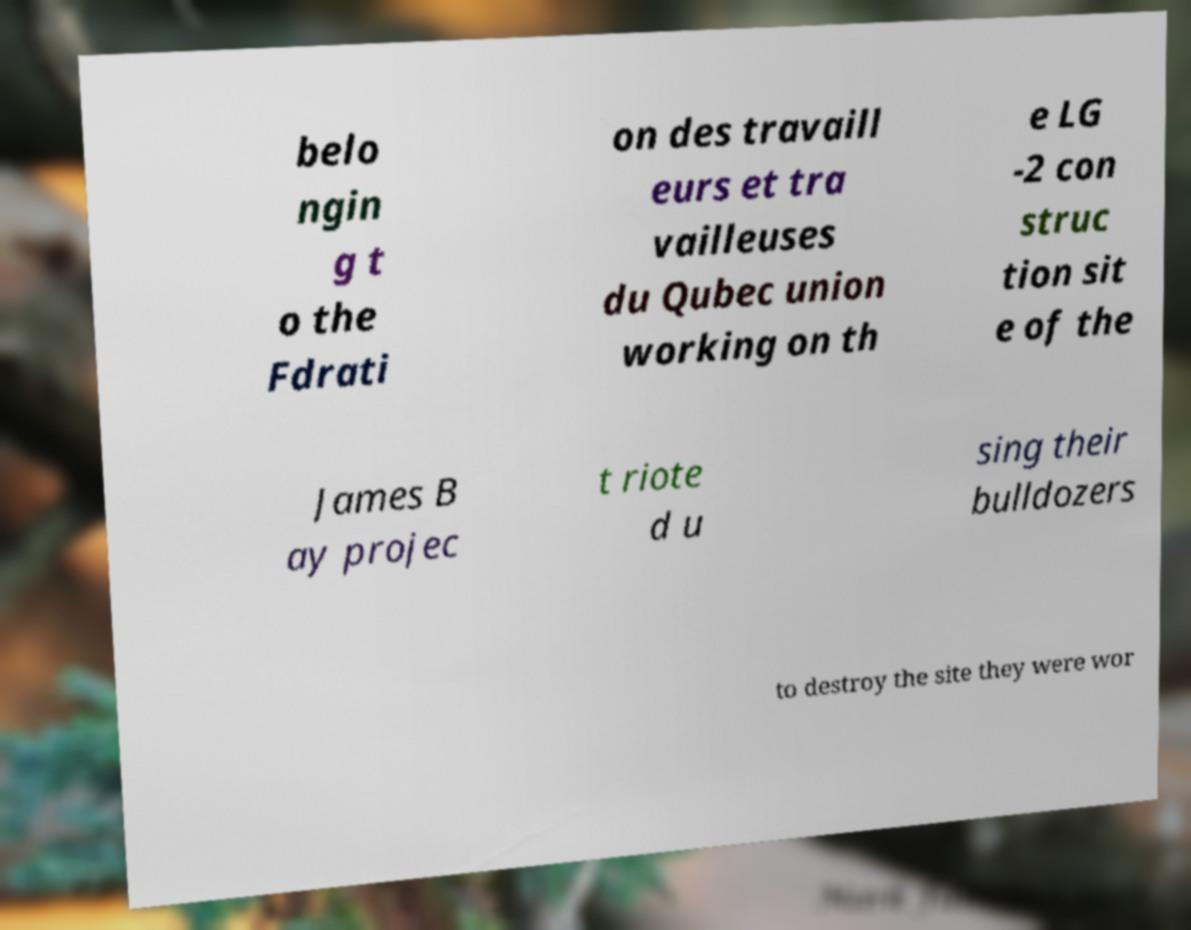Can you read and provide the text displayed in the image?This photo seems to have some interesting text. Can you extract and type it out for me? belo ngin g t o the Fdrati on des travaill eurs et tra vailleuses du Qubec union working on th e LG -2 con struc tion sit e of the James B ay projec t riote d u sing their bulldozers to destroy the site they were wor 